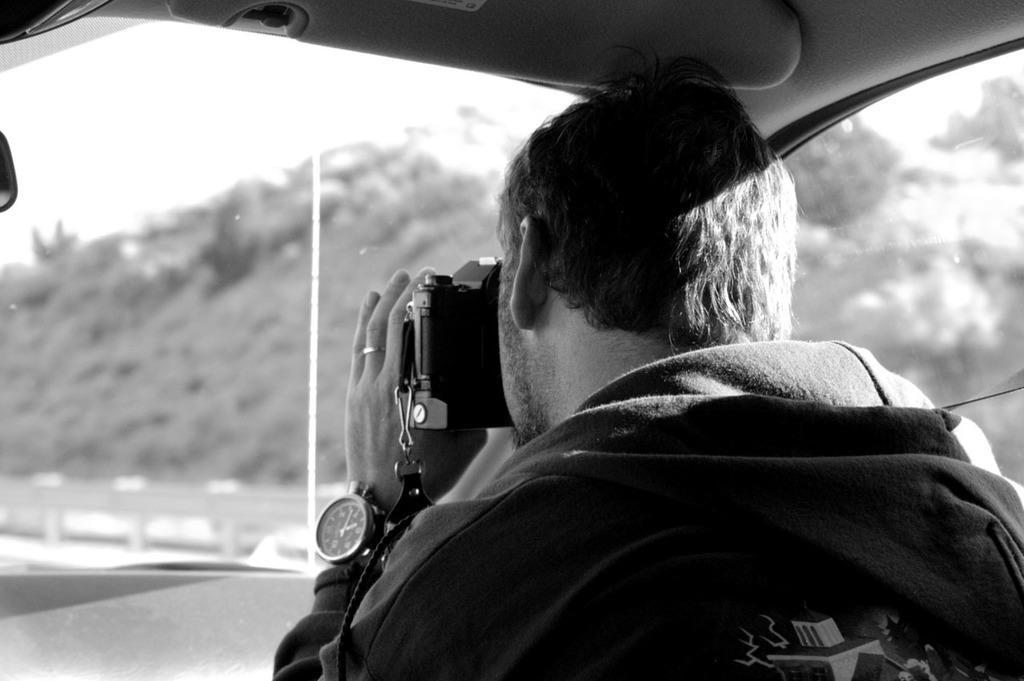Describe this image in one or two sentences. This image is taken inside the car. In the center of the image we can see a man sitting and holding a camera. In the background we can see hills and sky through the window glass. 